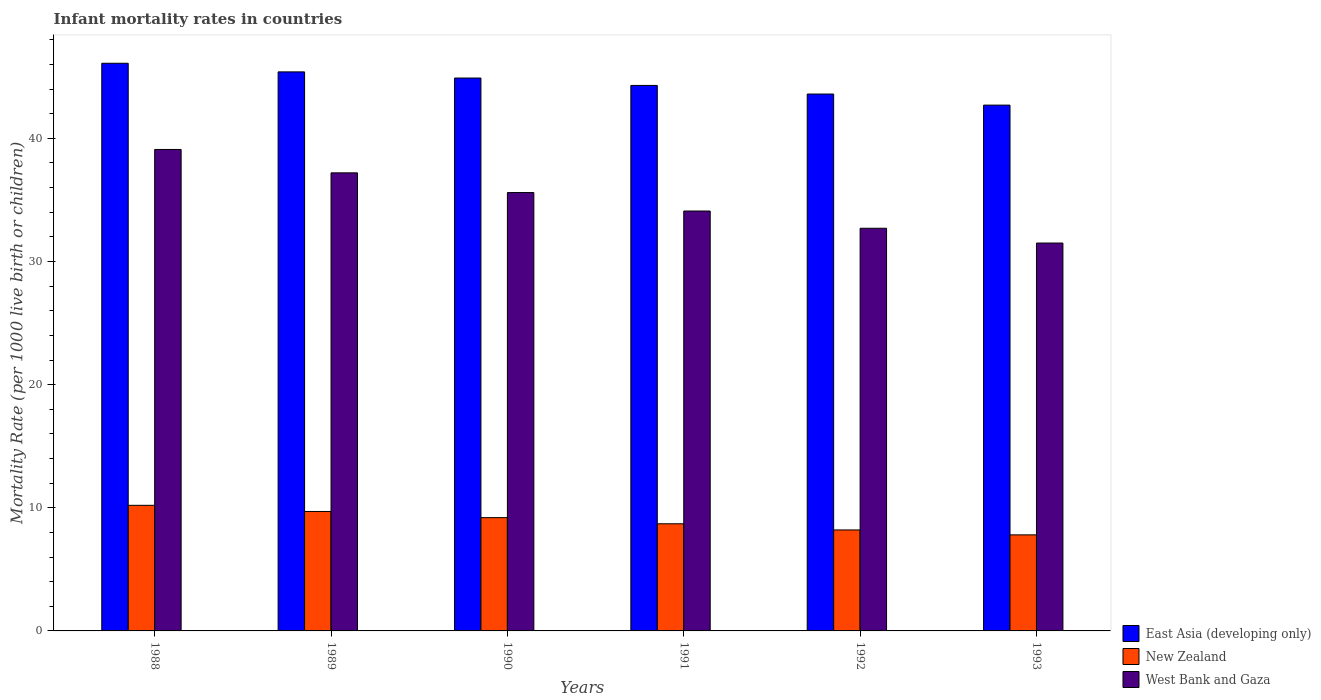How many groups of bars are there?
Ensure brevity in your answer.  6. Are the number of bars per tick equal to the number of legend labels?
Your answer should be very brief. Yes. How many bars are there on the 6th tick from the left?
Ensure brevity in your answer.  3. What is the label of the 2nd group of bars from the left?
Your answer should be very brief. 1989. In how many cases, is the number of bars for a given year not equal to the number of legend labels?
Provide a succinct answer. 0. What is the infant mortality rate in West Bank and Gaza in 1992?
Provide a succinct answer. 32.7. Across all years, what is the maximum infant mortality rate in West Bank and Gaza?
Ensure brevity in your answer.  39.1. Across all years, what is the minimum infant mortality rate in East Asia (developing only)?
Offer a terse response. 42.7. What is the total infant mortality rate in East Asia (developing only) in the graph?
Keep it short and to the point. 267. What is the difference between the infant mortality rate in East Asia (developing only) in 1991 and that in 1992?
Your answer should be very brief. 0.7. What is the difference between the infant mortality rate in East Asia (developing only) in 1992 and the infant mortality rate in New Zealand in 1989?
Keep it short and to the point. 33.9. What is the average infant mortality rate in East Asia (developing only) per year?
Ensure brevity in your answer.  44.5. In the year 1989, what is the difference between the infant mortality rate in New Zealand and infant mortality rate in West Bank and Gaza?
Your answer should be very brief. -27.5. What is the ratio of the infant mortality rate in East Asia (developing only) in 1989 to that in 1993?
Give a very brief answer. 1.06. What is the difference between the highest and the second highest infant mortality rate in West Bank and Gaza?
Offer a terse response. 1.9. What is the difference between the highest and the lowest infant mortality rate in West Bank and Gaza?
Make the answer very short. 7.6. In how many years, is the infant mortality rate in East Asia (developing only) greater than the average infant mortality rate in East Asia (developing only) taken over all years?
Provide a succinct answer. 3. Is the sum of the infant mortality rate in East Asia (developing only) in 1990 and 1993 greater than the maximum infant mortality rate in New Zealand across all years?
Your response must be concise. Yes. What does the 2nd bar from the left in 1992 represents?
Your answer should be compact. New Zealand. What does the 2nd bar from the right in 1992 represents?
Provide a succinct answer. New Zealand. Is it the case that in every year, the sum of the infant mortality rate in West Bank and Gaza and infant mortality rate in New Zealand is greater than the infant mortality rate in East Asia (developing only)?
Keep it short and to the point. No. Are all the bars in the graph horizontal?
Your answer should be compact. No. What is the difference between two consecutive major ticks on the Y-axis?
Your answer should be compact. 10. Does the graph contain any zero values?
Provide a succinct answer. No. Does the graph contain grids?
Give a very brief answer. No. Where does the legend appear in the graph?
Make the answer very short. Bottom right. How many legend labels are there?
Your answer should be compact. 3. How are the legend labels stacked?
Ensure brevity in your answer.  Vertical. What is the title of the graph?
Offer a very short reply. Infant mortality rates in countries. What is the label or title of the X-axis?
Offer a terse response. Years. What is the label or title of the Y-axis?
Your answer should be very brief. Mortality Rate (per 1000 live birth or children). What is the Mortality Rate (per 1000 live birth or children) in East Asia (developing only) in 1988?
Keep it short and to the point. 46.1. What is the Mortality Rate (per 1000 live birth or children) in New Zealand in 1988?
Your answer should be very brief. 10.2. What is the Mortality Rate (per 1000 live birth or children) in West Bank and Gaza in 1988?
Provide a succinct answer. 39.1. What is the Mortality Rate (per 1000 live birth or children) in East Asia (developing only) in 1989?
Your response must be concise. 45.4. What is the Mortality Rate (per 1000 live birth or children) of West Bank and Gaza in 1989?
Offer a terse response. 37.2. What is the Mortality Rate (per 1000 live birth or children) in East Asia (developing only) in 1990?
Your response must be concise. 44.9. What is the Mortality Rate (per 1000 live birth or children) of New Zealand in 1990?
Provide a short and direct response. 9.2. What is the Mortality Rate (per 1000 live birth or children) of West Bank and Gaza in 1990?
Your answer should be very brief. 35.6. What is the Mortality Rate (per 1000 live birth or children) in East Asia (developing only) in 1991?
Keep it short and to the point. 44.3. What is the Mortality Rate (per 1000 live birth or children) in West Bank and Gaza in 1991?
Keep it short and to the point. 34.1. What is the Mortality Rate (per 1000 live birth or children) of East Asia (developing only) in 1992?
Provide a succinct answer. 43.6. What is the Mortality Rate (per 1000 live birth or children) of West Bank and Gaza in 1992?
Provide a succinct answer. 32.7. What is the Mortality Rate (per 1000 live birth or children) of East Asia (developing only) in 1993?
Provide a short and direct response. 42.7. What is the Mortality Rate (per 1000 live birth or children) of New Zealand in 1993?
Provide a succinct answer. 7.8. What is the Mortality Rate (per 1000 live birth or children) in West Bank and Gaza in 1993?
Provide a succinct answer. 31.5. Across all years, what is the maximum Mortality Rate (per 1000 live birth or children) of East Asia (developing only)?
Offer a terse response. 46.1. Across all years, what is the maximum Mortality Rate (per 1000 live birth or children) in New Zealand?
Keep it short and to the point. 10.2. Across all years, what is the maximum Mortality Rate (per 1000 live birth or children) of West Bank and Gaza?
Provide a short and direct response. 39.1. Across all years, what is the minimum Mortality Rate (per 1000 live birth or children) of East Asia (developing only)?
Provide a short and direct response. 42.7. Across all years, what is the minimum Mortality Rate (per 1000 live birth or children) in West Bank and Gaza?
Your response must be concise. 31.5. What is the total Mortality Rate (per 1000 live birth or children) in East Asia (developing only) in the graph?
Ensure brevity in your answer.  267. What is the total Mortality Rate (per 1000 live birth or children) of New Zealand in the graph?
Provide a short and direct response. 53.8. What is the total Mortality Rate (per 1000 live birth or children) in West Bank and Gaza in the graph?
Give a very brief answer. 210.2. What is the difference between the Mortality Rate (per 1000 live birth or children) of East Asia (developing only) in 1988 and that in 1989?
Make the answer very short. 0.7. What is the difference between the Mortality Rate (per 1000 live birth or children) in West Bank and Gaza in 1988 and that in 1989?
Make the answer very short. 1.9. What is the difference between the Mortality Rate (per 1000 live birth or children) of East Asia (developing only) in 1988 and that in 1991?
Offer a terse response. 1.8. What is the difference between the Mortality Rate (per 1000 live birth or children) in New Zealand in 1988 and that in 1991?
Offer a very short reply. 1.5. What is the difference between the Mortality Rate (per 1000 live birth or children) in West Bank and Gaza in 1988 and that in 1991?
Keep it short and to the point. 5. What is the difference between the Mortality Rate (per 1000 live birth or children) of East Asia (developing only) in 1988 and that in 1992?
Offer a very short reply. 2.5. What is the difference between the Mortality Rate (per 1000 live birth or children) in West Bank and Gaza in 1988 and that in 1992?
Your answer should be very brief. 6.4. What is the difference between the Mortality Rate (per 1000 live birth or children) of East Asia (developing only) in 1988 and that in 1993?
Your answer should be very brief. 3.4. What is the difference between the Mortality Rate (per 1000 live birth or children) of New Zealand in 1989 and that in 1990?
Provide a short and direct response. 0.5. What is the difference between the Mortality Rate (per 1000 live birth or children) of West Bank and Gaza in 1989 and that in 1990?
Your answer should be very brief. 1.6. What is the difference between the Mortality Rate (per 1000 live birth or children) in East Asia (developing only) in 1989 and that in 1991?
Your answer should be compact. 1.1. What is the difference between the Mortality Rate (per 1000 live birth or children) of West Bank and Gaza in 1989 and that in 1991?
Keep it short and to the point. 3.1. What is the difference between the Mortality Rate (per 1000 live birth or children) in New Zealand in 1989 and that in 1992?
Ensure brevity in your answer.  1.5. What is the difference between the Mortality Rate (per 1000 live birth or children) of New Zealand in 1990 and that in 1992?
Offer a very short reply. 1. What is the difference between the Mortality Rate (per 1000 live birth or children) in East Asia (developing only) in 1990 and that in 1993?
Provide a succinct answer. 2.2. What is the difference between the Mortality Rate (per 1000 live birth or children) in East Asia (developing only) in 1991 and that in 1992?
Offer a terse response. 0.7. What is the difference between the Mortality Rate (per 1000 live birth or children) in West Bank and Gaza in 1991 and that in 1992?
Provide a succinct answer. 1.4. What is the difference between the Mortality Rate (per 1000 live birth or children) in East Asia (developing only) in 1991 and that in 1993?
Offer a terse response. 1.6. What is the difference between the Mortality Rate (per 1000 live birth or children) of New Zealand in 1991 and that in 1993?
Your answer should be very brief. 0.9. What is the difference between the Mortality Rate (per 1000 live birth or children) of West Bank and Gaza in 1991 and that in 1993?
Offer a terse response. 2.6. What is the difference between the Mortality Rate (per 1000 live birth or children) of East Asia (developing only) in 1992 and that in 1993?
Keep it short and to the point. 0.9. What is the difference between the Mortality Rate (per 1000 live birth or children) of New Zealand in 1992 and that in 1993?
Make the answer very short. 0.4. What is the difference between the Mortality Rate (per 1000 live birth or children) of West Bank and Gaza in 1992 and that in 1993?
Provide a succinct answer. 1.2. What is the difference between the Mortality Rate (per 1000 live birth or children) of East Asia (developing only) in 1988 and the Mortality Rate (per 1000 live birth or children) of New Zealand in 1989?
Ensure brevity in your answer.  36.4. What is the difference between the Mortality Rate (per 1000 live birth or children) of East Asia (developing only) in 1988 and the Mortality Rate (per 1000 live birth or children) of New Zealand in 1990?
Make the answer very short. 36.9. What is the difference between the Mortality Rate (per 1000 live birth or children) of East Asia (developing only) in 1988 and the Mortality Rate (per 1000 live birth or children) of West Bank and Gaza in 1990?
Provide a succinct answer. 10.5. What is the difference between the Mortality Rate (per 1000 live birth or children) in New Zealand in 1988 and the Mortality Rate (per 1000 live birth or children) in West Bank and Gaza in 1990?
Make the answer very short. -25.4. What is the difference between the Mortality Rate (per 1000 live birth or children) in East Asia (developing only) in 1988 and the Mortality Rate (per 1000 live birth or children) in New Zealand in 1991?
Provide a succinct answer. 37.4. What is the difference between the Mortality Rate (per 1000 live birth or children) in New Zealand in 1988 and the Mortality Rate (per 1000 live birth or children) in West Bank and Gaza in 1991?
Give a very brief answer. -23.9. What is the difference between the Mortality Rate (per 1000 live birth or children) in East Asia (developing only) in 1988 and the Mortality Rate (per 1000 live birth or children) in New Zealand in 1992?
Make the answer very short. 37.9. What is the difference between the Mortality Rate (per 1000 live birth or children) in East Asia (developing only) in 1988 and the Mortality Rate (per 1000 live birth or children) in West Bank and Gaza in 1992?
Offer a very short reply. 13.4. What is the difference between the Mortality Rate (per 1000 live birth or children) of New Zealand in 1988 and the Mortality Rate (per 1000 live birth or children) of West Bank and Gaza in 1992?
Provide a succinct answer. -22.5. What is the difference between the Mortality Rate (per 1000 live birth or children) in East Asia (developing only) in 1988 and the Mortality Rate (per 1000 live birth or children) in New Zealand in 1993?
Make the answer very short. 38.3. What is the difference between the Mortality Rate (per 1000 live birth or children) of New Zealand in 1988 and the Mortality Rate (per 1000 live birth or children) of West Bank and Gaza in 1993?
Offer a very short reply. -21.3. What is the difference between the Mortality Rate (per 1000 live birth or children) in East Asia (developing only) in 1989 and the Mortality Rate (per 1000 live birth or children) in New Zealand in 1990?
Ensure brevity in your answer.  36.2. What is the difference between the Mortality Rate (per 1000 live birth or children) of New Zealand in 1989 and the Mortality Rate (per 1000 live birth or children) of West Bank and Gaza in 1990?
Keep it short and to the point. -25.9. What is the difference between the Mortality Rate (per 1000 live birth or children) of East Asia (developing only) in 1989 and the Mortality Rate (per 1000 live birth or children) of New Zealand in 1991?
Offer a very short reply. 36.7. What is the difference between the Mortality Rate (per 1000 live birth or children) of East Asia (developing only) in 1989 and the Mortality Rate (per 1000 live birth or children) of West Bank and Gaza in 1991?
Keep it short and to the point. 11.3. What is the difference between the Mortality Rate (per 1000 live birth or children) of New Zealand in 1989 and the Mortality Rate (per 1000 live birth or children) of West Bank and Gaza in 1991?
Give a very brief answer. -24.4. What is the difference between the Mortality Rate (per 1000 live birth or children) of East Asia (developing only) in 1989 and the Mortality Rate (per 1000 live birth or children) of New Zealand in 1992?
Make the answer very short. 37.2. What is the difference between the Mortality Rate (per 1000 live birth or children) in New Zealand in 1989 and the Mortality Rate (per 1000 live birth or children) in West Bank and Gaza in 1992?
Keep it short and to the point. -23. What is the difference between the Mortality Rate (per 1000 live birth or children) of East Asia (developing only) in 1989 and the Mortality Rate (per 1000 live birth or children) of New Zealand in 1993?
Keep it short and to the point. 37.6. What is the difference between the Mortality Rate (per 1000 live birth or children) in New Zealand in 1989 and the Mortality Rate (per 1000 live birth or children) in West Bank and Gaza in 1993?
Your answer should be compact. -21.8. What is the difference between the Mortality Rate (per 1000 live birth or children) of East Asia (developing only) in 1990 and the Mortality Rate (per 1000 live birth or children) of New Zealand in 1991?
Provide a short and direct response. 36.2. What is the difference between the Mortality Rate (per 1000 live birth or children) in New Zealand in 1990 and the Mortality Rate (per 1000 live birth or children) in West Bank and Gaza in 1991?
Your answer should be compact. -24.9. What is the difference between the Mortality Rate (per 1000 live birth or children) of East Asia (developing only) in 1990 and the Mortality Rate (per 1000 live birth or children) of New Zealand in 1992?
Give a very brief answer. 36.7. What is the difference between the Mortality Rate (per 1000 live birth or children) in New Zealand in 1990 and the Mortality Rate (per 1000 live birth or children) in West Bank and Gaza in 1992?
Your answer should be very brief. -23.5. What is the difference between the Mortality Rate (per 1000 live birth or children) in East Asia (developing only) in 1990 and the Mortality Rate (per 1000 live birth or children) in New Zealand in 1993?
Offer a terse response. 37.1. What is the difference between the Mortality Rate (per 1000 live birth or children) in New Zealand in 1990 and the Mortality Rate (per 1000 live birth or children) in West Bank and Gaza in 1993?
Make the answer very short. -22.3. What is the difference between the Mortality Rate (per 1000 live birth or children) in East Asia (developing only) in 1991 and the Mortality Rate (per 1000 live birth or children) in New Zealand in 1992?
Provide a short and direct response. 36.1. What is the difference between the Mortality Rate (per 1000 live birth or children) of New Zealand in 1991 and the Mortality Rate (per 1000 live birth or children) of West Bank and Gaza in 1992?
Provide a short and direct response. -24. What is the difference between the Mortality Rate (per 1000 live birth or children) in East Asia (developing only) in 1991 and the Mortality Rate (per 1000 live birth or children) in New Zealand in 1993?
Your response must be concise. 36.5. What is the difference between the Mortality Rate (per 1000 live birth or children) in New Zealand in 1991 and the Mortality Rate (per 1000 live birth or children) in West Bank and Gaza in 1993?
Give a very brief answer. -22.8. What is the difference between the Mortality Rate (per 1000 live birth or children) of East Asia (developing only) in 1992 and the Mortality Rate (per 1000 live birth or children) of New Zealand in 1993?
Your answer should be compact. 35.8. What is the difference between the Mortality Rate (per 1000 live birth or children) in New Zealand in 1992 and the Mortality Rate (per 1000 live birth or children) in West Bank and Gaza in 1993?
Ensure brevity in your answer.  -23.3. What is the average Mortality Rate (per 1000 live birth or children) in East Asia (developing only) per year?
Your answer should be compact. 44.5. What is the average Mortality Rate (per 1000 live birth or children) of New Zealand per year?
Keep it short and to the point. 8.97. What is the average Mortality Rate (per 1000 live birth or children) of West Bank and Gaza per year?
Your response must be concise. 35.03. In the year 1988, what is the difference between the Mortality Rate (per 1000 live birth or children) of East Asia (developing only) and Mortality Rate (per 1000 live birth or children) of New Zealand?
Offer a very short reply. 35.9. In the year 1988, what is the difference between the Mortality Rate (per 1000 live birth or children) of East Asia (developing only) and Mortality Rate (per 1000 live birth or children) of West Bank and Gaza?
Provide a short and direct response. 7. In the year 1988, what is the difference between the Mortality Rate (per 1000 live birth or children) of New Zealand and Mortality Rate (per 1000 live birth or children) of West Bank and Gaza?
Offer a terse response. -28.9. In the year 1989, what is the difference between the Mortality Rate (per 1000 live birth or children) in East Asia (developing only) and Mortality Rate (per 1000 live birth or children) in New Zealand?
Make the answer very short. 35.7. In the year 1989, what is the difference between the Mortality Rate (per 1000 live birth or children) of New Zealand and Mortality Rate (per 1000 live birth or children) of West Bank and Gaza?
Your answer should be compact. -27.5. In the year 1990, what is the difference between the Mortality Rate (per 1000 live birth or children) of East Asia (developing only) and Mortality Rate (per 1000 live birth or children) of New Zealand?
Provide a short and direct response. 35.7. In the year 1990, what is the difference between the Mortality Rate (per 1000 live birth or children) in East Asia (developing only) and Mortality Rate (per 1000 live birth or children) in West Bank and Gaza?
Provide a succinct answer. 9.3. In the year 1990, what is the difference between the Mortality Rate (per 1000 live birth or children) in New Zealand and Mortality Rate (per 1000 live birth or children) in West Bank and Gaza?
Offer a very short reply. -26.4. In the year 1991, what is the difference between the Mortality Rate (per 1000 live birth or children) in East Asia (developing only) and Mortality Rate (per 1000 live birth or children) in New Zealand?
Offer a very short reply. 35.6. In the year 1991, what is the difference between the Mortality Rate (per 1000 live birth or children) of East Asia (developing only) and Mortality Rate (per 1000 live birth or children) of West Bank and Gaza?
Provide a succinct answer. 10.2. In the year 1991, what is the difference between the Mortality Rate (per 1000 live birth or children) in New Zealand and Mortality Rate (per 1000 live birth or children) in West Bank and Gaza?
Your answer should be very brief. -25.4. In the year 1992, what is the difference between the Mortality Rate (per 1000 live birth or children) of East Asia (developing only) and Mortality Rate (per 1000 live birth or children) of New Zealand?
Provide a short and direct response. 35.4. In the year 1992, what is the difference between the Mortality Rate (per 1000 live birth or children) of New Zealand and Mortality Rate (per 1000 live birth or children) of West Bank and Gaza?
Your answer should be very brief. -24.5. In the year 1993, what is the difference between the Mortality Rate (per 1000 live birth or children) in East Asia (developing only) and Mortality Rate (per 1000 live birth or children) in New Zealand?
Your answer should be compact. 34.9. In the year 1993, what is the difference between the Mortality Rate (per 1000 live birth or children) in East Asia (developing only) and Mortality Rate (per 1000 live birth or children) in West Bank and Gaza?
Give a very brief answer. 11.2. In the year 1993, what is the difference between the Mortality Rate (per 1000 live birth or children) in New Zealand and Mortality Rate (per 1000 live birth or children) in West Bank and Gaza?
Provide a short and direct response. -23.7. What is the ratio of the Mortality Rate (per 1000 live birth or children) in East Asia (developing only) in 1988 to that in 1989?
Your answer should be compact. 1.02. What is the ratio of the Mortality Rate (per 1000 live birth or children) in New Zealand in 1988 to that in 1989?
Your answer should be very brief. 1.05. What is the ratio of the Mortality Rate (per 1000 live birth or children) in West Bank and Gaza in 1988 to that in 1989?
Make the answer very short. 1.05. What is the ratio of the Mortality Rate (per 1000 live birth or children) in East Asia (developing only) in 1988 to that in 1990?
Ensure brevity in your answer.  1.03. What is the ratio of the Mortality Rate (per 1000 live birth or children) of New Zealand in 1988 to that in 1990?
Your response must be concise. 1.11. What is the ratio of the Mortality Rate (per 1000 live birth or children) in West Bank and Gaza in 1988 to that in 1990?
Give a very brief answer. 1.1. What is the ratio of the Mortality Rate (per 1000 live birth or children) in East Asia (developing only) in 1988 to that in 1991?
Offer a terse response. 1.04. What is the ratio of the Mortality Rate (per 1000 live birth or children) in New Zealand in 1988 to that in 1991?
Your response must be concise. 1.17. What is the ratio of the Mortality Rate (per 1000 live birth or children) of West Bank and Gaza in 1988 to that in 1991?
Give a very brief answer. 1.15. What is the ratio of the Mortality Rate (per 1000 live birth or children) of East Asia (developing only) in 1988 to that in 1992?
Keep it short and to the point. 1.06. What is the ratio of the Mortality Rate (per 1000 live birth or children) of New Zealand in 1988 to that in 1992?
Keep it short and to the point. 1.24. What is the ratio of the Mortality Rate (per 1000 live birth or children) in West Bank and Gaza in 1988 to that in 1992?
Offer a very short reply. 1.2. What is the ratio of the Mortality Rate (per 1000 live birth or children) of East Asia (developing only) in 1988 to that in 1993?
Offer a very short reply. 1.08. What is the ratio of the Mortality Rate (per 1000 live birth or children) of New Zealand in 1988 to that in 1993?
Ensure brevity in your answer.  1.31. What is the ratio of the Mortality Rate (per 1000 live birth or children) of West Bank and Gaza in 1988 to that in 1993?
Provide a short and direct response. 1.24. What is the ratio of the Mortality Rate (per 1000 live birth or children) of East Asia (developing only) in 1989 to that in 1990?
Make the answer very short. 1.01. What is the ratio of the Mortality Rate (per 1000 live birth or children) in New Zealand in 1989 to that in 1990?
Offer a terse response. 1.05. What is the ratio of the Mortality Rate (per 1000 live birth or children) of West Bank and Gaza in 1989 to that in 1990?
Your answer should be compact. 1.04. What is the ratio of the Mortality Rate (per 1000 live birth or children) in East Asia (developing only) in 1989 to that in 1991?
Provide a succinct answer. 1.02. What is the ratio of the Mortality Rate (per 1000 live birth or children) in New Zealand in 1989 to that in 1991?
Your answer should be very brief. 1.11. What is the ratio of the Mortality Rate (per 1000 live birth or children) in East Asia (developing only) in 1989 to that in 1992?
Offer a very short reply. 1.04. What is the ratio of the Mortality Rate (per 1000 live birth or children) of New Zealand in 1989 to that in 1992?
Give a very brief answer. 1.18. What is the ratio of the Mortality Rate (per 1000 live birth or children) in West Bank and Gaza in 1989 to that in 1992?
Ensure brevity in your answer.  1.14. What is the ratio of the Mortality Rate (per 1000 live birth or children) of East Asia (developing only) in 1989 to that in 1993?
Provide a short and direct response. 1.06. What is the ratio of the Mortality Rate (per 1000 live birth or children) of New Zealand in 1989 to that in 1993?
Your answer should be very brief. 1.24. What is the ratio of the Mortality Rate (per 1000 live birth or children) in West Bank and Gaza in 1989 to that in 1993?
Your answer should be compact. 1.18. What is the ratio of the Mortality Rate (per 1000 live birth or children) of East Asia (developing only) in 1990 to that in 1991?
Offer a terse response. 1.01. What is the ratio of the Mortality Rate (per 1000 live birth or children) in New Zealand in 1990 to that in 1991?
Your answer should be very brief. 1.06. What is the ratio of the Mortality Rate (per 1000 live birth or children) in West Bank and Gaza in 1990 to that in 1991?
Ensure brevity in your answer.  1.04. What is the ratio of the Mortality Rate (per 1000 live birth or children) of East Asia (developing only) in 1990 to that in 1992?
Your answer should be very brief. 1.03. What is the ratio of the Mortality Rate (per 1000 live birth or children) of New Zealand in 1990 to that in 1992?
Ensure brevity in your answer.  1.12. What is the ratio of the Mortality Rate (per 1000 live birth or children) of West Bank and Gaza in 1990 to that in 1992?
Your response must be concise. 1.09. What is the ratio of the Mortality Rate (per 1000 live birth or children) in East Asia (developing only) in 1990 to that in 1993?
Ensure brevity in your answer.  1.05. What is the ratio of the Mortality Rate (per 1000 live birth or children) in New Zealand in 1990 to that in 1993?
Your answer should be compact. 1.18. What is the ratio of the Mortality Rate (per 1000 live birth or children) of West Bank and Gaza in 1990 to that in 1993?
Your response must be concise. 1.13. What is the ratio of the Mortality Rate (per 1000 live birth or children) of East Asia (developing only) in 1991 to that in 1992?
Provide a succinct answer. 1.02. What is the ratio of the Mortality Rate (per 1000 live birth or children) of New Zealand in 1991 to that in 1992?
Provide a succinct answer. 1.06. What is the ratio of the Mortality Rate (per 1000 live birth or children) of West Bank and Gaza in 1991 to that in 1992?
Your response must be concise. 1.04. What is the ratio of the Mortality Rate (per 1000 live birth or children) in East Asia (developing only) in 1991 to that in 1993?
Your answer should be very brief. 1.04. What is the ratio of the Mortality Rate (per 1000 live birth or children) of New Zealand in 1991 to that in 1993?
Make the answer very short. 1.12. What is the ratio of the Mortality Rate (per 1000 live birth or children) of West Bank and Gaza in 1991 to that in 1993?
Offer a very short reply. 1.08. What is the ratio of the Mortality Rate (per 1000 live birth or children) in East Asia (developing only) in 1992 to that in 1993?
Keep it short and to the point. 1.02. What is the ratio of the Mortality Rate (per 1000 live birth or children) in New Zealand in 1992 to that in 1993?
Make the answer very short. 1.05. What is the ratio of the Mortality Rate (per 1000 live birth or children) in West Bank and Gaza in 1992 to that in 1993?
Offer a terse response. 1.04. What is the difference between the highest and the second highest Mortality Rate (per 1000 live birth or children) in East Asia (developing only)?
Provide a short and direct response. 0.7. What is the difference between the highest and the second highest Mortality Rate (per 1000 live birth or children) in New Zealand?
Offer a very short reply. 0.5. What is the difference between the highest and the lowest Mortality Rate (per 1000 live birth or children) of New Zealand?
Ensure brevity in your answer.  2.4. 